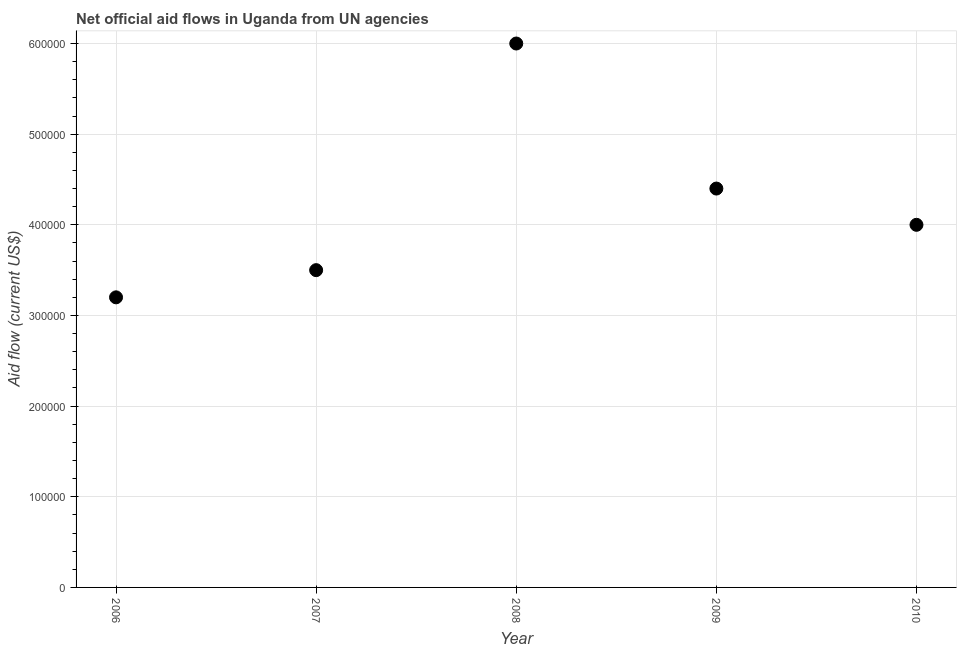What is the net official flows from un agencies in 2007?
Your response must be concise. 3.50e+05. Across all years, what is the maximum net official flows from un agencies?
Provide a succinct answer. 6.00e+05. Across all years, what is the minimum net official flows from un agencies?
Offer a terse response. 3.20e+05. In which year was the net official flows from un agencies maximum?
Provide a short and direct response. 2008. In which year was the net official flows from un agencies minimum?
Give a very brief answer. 2006. What is the sum of the net official flows from un agencies?
Offer a terse response. 2.11e+06. What is the difference between the net official flows from un agencies in 2007 and 2009?
Provide a short and direct response. -9.00e+04. What is the average net official flows from un agencies per year?
Give a very brief answer. 4.22e+05. What is the ratio of the net official flows from un agencies in 2006 to that in 2007?
Offer a very short reply. 0.91. Is the net official flows from un agencies in 2008 less than that in 2009?
Provide a succinct answer. No. Is the difference between the net official flows from un agencies in 2006 and 2009 greater than the difference between any two years?
Keep it short and to the point. No. What is the difference between the highest and the second highest net official flows from un agencies?
Offer a very short reply. 1.60e+05. Is the sum of the net official flows from un agencies in 2008 and 2009 greater than the maximum net official flows from un agencies across all years?
Your answer should be very brief. Yes. What is the difference between the highest and the lowest net official flows from un agencies?
Your answer should be very brief. 2.80e+05. How many years are there in the graph?
Offer a very short reply. 5. What is the difference between two consecutive major ticks on the Y-axis?
Your answer should be very brief. 1.00e+05. Does the graph contain grids?
Your response must be concise. Yes. What is the title of the graph?
Offer a terse response. Net official aid flows in Uganda from UN agencies. What is the label or title of the X-axis?
Offer a very short reply. Year. What is the Aid flow (current US$) in 2006?
Offer a very short reply. 3.20e+05. What is the Aid flow (current US$) in 2007?
Your answer should be compact. 3.50e+05. What is the difference between the Aid flow (current US$) in 2006 and 2008?
Ensure brevity in your answer.  -2.80e+05. What is the difference between the Aid flow (current US$) in 2007 and 2010?
Keep it short and to the point. -5.00e+04. What is the difference between the Aid flow (current US$) in 2008 and 2010?
Your answer should be very brief. 2.00e+05. What is the ratio of the Aid flow (current US$) in 2006 to that in 2007?
Offer a very short reply. 0.91. What is the ratio of the Aid flow (current US$) in 2006 to that in 2008?
Offer a terse response. 0.53. What is the ratio of the Aid flow (current US$) in 2006 to that in 2009?
Offer a terse response. 0.73. What is the ratio of the Aid flow (current US$) in 2006 to that in 2010?
Your answer should be compact. 0.8. What is the ratio of the Aid flow (current US$) in 2007 to that in 2008?
Provide a succinct answer. 0.58. What is the ratio of the Aid flow (current US$) in 2007 to that in 2009?
Your response must be concise. 0.8. What is the ratio of the Aid flow (current US$) in 2007 to that in 2010?
Make the answer very short. 0.88. What is the ratio of the Aid flow (current US$) in 2008 to that in 2009?
Offer a very short reply. 1.36. What is the ratio of the Aid flow (current US$) in 2009 to that in 2010?
Keep it short and to the point. 1.1. 